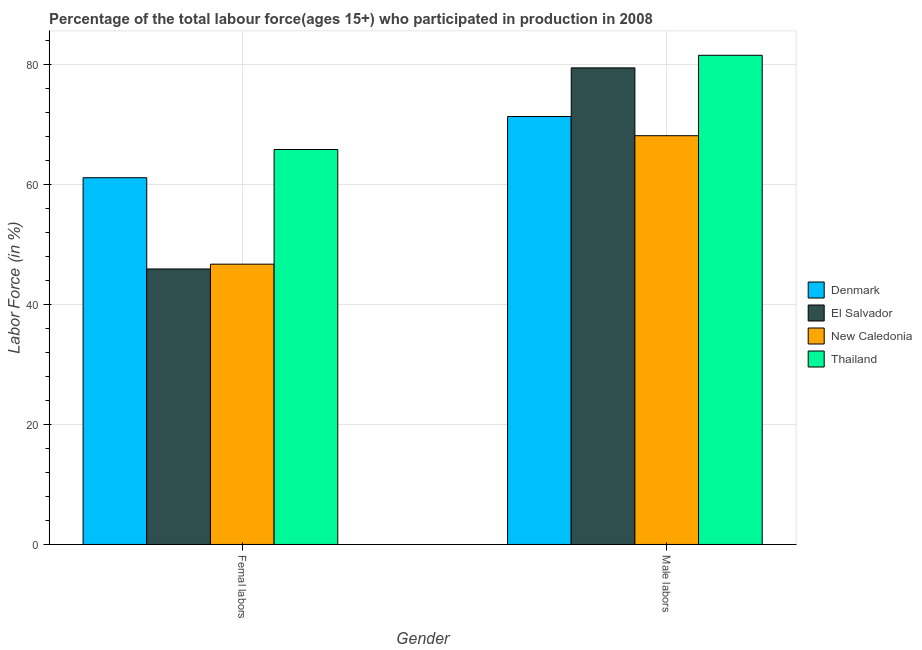How many different coloured bars are there?
Offer a very short reply. 4. Are the number of bars on each tick of the X-axis equal?
Your answer should be compact. Yes. What is the label of the 2nd group of bars from the left?
Offer a terse response. Male labors. What is the percentage of female labor force in New Caledonia?
Offer a very short reply. 46.7. Across all countries, what is the maximum percentage of female labor force?
Provide a succinct answer. 65.8. Across all countries, what is the minimum percentage of female labor force?
Make the answer very short. 45.9. In which country was the percentage of male labour force maximum?
Provide a short and direct response. Thailand. In which country was the percentage of female labor force minimum?
Your answer should be compact. El Salvador. What is the total percentage of male labour force in the graph?
Provide a short and direct response. 300.3. What is the difference between the percentage of male labour force in Denmark and that in El Salvador?
Provide a short and direct response. -8.1. What is the difference between the percentage of female labor force in Denmark and the percentage of male labour force in El Salvador?
Keep it short and to the point. -18.3. What is the average percentage of female labor force per country?
Provide a succinct answer. 54.88. What is the difference between the percentage of female labor force and percentage of male labour force in New Caledonia?
Offer a terse response. -21.4. In how many countries, is the percentage of male labour force greater than 40 %?
Ensure brevity in your answer.  4. What is the ratio of the percentage of male labour force in El Salvador to that in Thailand?
Ensure brevity in your answer.  0.97. In how many countries, is the percentage of female labor force greater than the average percentage of female labor force taken over all countries?
Give a very brief answer. 2. What does the 1st bar from the left in Male labors represents?
Offer a very short reply. Denmark. What does the 2nd bar from the right in Male labors represents?
Your response must be concise. New Caledonia. Are all the bars in the graph horizontal?
Provide a succinct answer. No. How many countries are there in the graph?
Give a very brief answer. 4. Are the values on the major ticks of Y-axis written in scientific E-notation?
Keep it short and to the point. No. Does the graph contain any zero values?
Your answer should be very brief. No. Does the graph contain grids?
Ensure brevity in your answer.  Yes. Where does the legend appear in the graph?
Ensure brevity in your answer.  Center right. How many legend labels are there?
Provide a short and direct response. 4. How are the legend labels stacked?
Provide a short and direct response. Vertical. What is the title of the graph?
Make the answer very short. Percentage of the total labour force(ages 15+) who participated in production in 2008. What is the Labor Force (in %) in Denmark in Femal labors?
Make the answer very short. 61.1. What is the Labor Force (in %) of El Salvador in Femal labors?
Make the answer very short. 45.9. What is the Labor Force (in %) in New Caledonia in Femal labors?
Provide a short and direct response. 46.7. What is the Labor Force (in %) in Thailand in Femal labors?
Provide a succinct answer. 65.8. What is the Labor Force (in %) of Denmark in Male labors?
Your answer should be very brief. 71.3. What is the Labor Force (in %) in El Salvador in Male labors?
Make the answer very short. 79.4. What is the Labor Force (in %) in New Caledonia in Male labors?
Offer a terse response. 68.1. What is the Labor Force (in %) in Thailand in Male labors?
Provide a short and direct response. 81.5. Across all Gender, what is the maximum Labor Force (in %) in Denmark?
Offer a very short reply. 71.3. Across all Gender, what is the maximum Labor Force (in %) in El Salvador?
Your answer should be very brief. 79.4. Across all Gender, what is the maximum Labor Force (in %) of New Caledonia?
Your response must be concise. 68.1. Across all Gender, what is the maximum Labor Force (in %) of Thailand?
Your answer should be very brief. 81.5. Across all Gender, what is the minimum Labor Force (in %) of Denmark?
Your response must be concise. 61.1. Across all Gender, what is the minimum Labor Force (in %) of El Salvador?
Keep it short and to the point. 45.9. Across all Gender, what is the minimum Labor Force (in %) in New Caledonia?
Provide a short and direct response. 46.7. Across all Gender, what is the minimum Labor Force (in %) in Thailand?
Provide a short and direct response. 65.8. What is the total Labor Force (in %) of Denmark in the graph?
Your answer should be compact. 132.4. What is the total Labor Force (in %) in El Salvador in the graph?
Make the answer very short. 125.3. What is the total Labor Force (in %) of New Caledonia in the graph?
Provide a short and direct response. 114.8. What is the total Labor Force (in %) of Thailand in the graph?
Offer a terse response. 147.3. What is the difference between the Labor Force (in %) in Denmark in Femal labors and that in Male labors?
Provide a short and direct response. -10.2. What is the difference between the Labor Force (in %) in El Salvador in Femal labors and that in Male labors?
Provide a short and direct response. -33.5. What is the difference between the Labor Force (in %) in New Caledonia in Femal labors and that in Male labors?
Give a very brief answer. -21.4. What is the difference between the Labor Force (in %) of Thailand in Femal labors and that in Male labors?
Ensure brevity in your answer.  -15.7. What is the difference between the Labor Force (in %) of Denmark in Femal labors and the Labor Force (in %) of El Salvador in Male labors?
Ensure brevity in your answer.  -18.3. What is the difference between the Labor Force (in %) of Denmark in Femal labors and the Labor Force (in %) of Thailand in Male labors?
Offer a terse response. -20.4. What is the difference between the Labor Force (in %) of El Salvador in Femal labors and the Labor Force (in %) of New Caledonia in Male labors?
Offer a very short reply. -22.2. What is the difference between the Labor Force (in %) of El Salvador in Femal labors and the Labor Force (in %) of Thailand in Male labors?
Offer a very short reply. -35.6. What is the difference between the Labor Force (in %) of New Caledonia in Femal labors and the Labor Force (in %) of Thailand in Male labors?
Provide a succinct answer. -34.8. What is the average Labor Force (in %) in Denmark per Gender?
Provide a succinct answer. 66.2. What is the average Labor Force (in %) of El Salvador per Gender?
Keep it short and to the point. 62.65. What is the average Labor Force (in %) in New Caledonia per Gender?
Your response must be concise. 57.4. What is the average Labor Force (in %) of Thailand per Gender?
Provide a short and direct response. 73.65. What is the difference between the Labor Force (in %) in Denmark and Labor Force (in %) in El Salvador in Femal labors?
Give a very brief answer. 15.2. What is the difference between the Labor Force (in %) of Denmark and Labor Force (in %) of New Caledonia in Femal labors?
Make the answer very short. 14.4. What is the difference between the Labor Force (in %) of Denmark and Labor Force (in %) of Thailand in Femal labors?
Keep it short and to the point. -4.7. What is the difference between the Labor Force (in %) in El Salvador and Labor Force (in %) in New Caledonia in Femal labors?
Your answer should be compact. -0.8. What is the difference between the Labor Force (in %) of El Salvador and Labor Force (in %) of Thailand in Femal labors?
Offer a terse response. -19.9. What is the difference between the Labor Force (in %) in New Caledonia and Labor Force (in %) in Thailand in Femal labors?
Make the answer very short. -19.1. What is the difference between the Labor Force (in %) of Denmark and Labor Force (in %) of El Salvador in Male labors?
Your response must be concise. -8.1. What is the difference between the Labor Force (in %) in Denmark and Labor Force (in %) in Thailand in Male labors?
Give a very brief answer. -10.2. What is the ratio of the Labor Force (in %) in Denmark in Femal labors to that in Male labors?
Provide a short and direct response. 0.86. What is the ratio of the Labor Force (in %) of El Salvador in Femal labors to that in Male labors?
Your answer should be very brief. 0.58. What is the ratio of the Labor Force (in %) of New Caledonia in Femal labors to that in Male labors?
Ensure brevity in your answer.  0.69. What is the ratio of the Labor Force (in %) in Thailand in Femal labors to that in Male labors?
Ensure brevity in your answer.  0.81. What is the difference between the highest and the second highest Labor Force (in %) of El Salvador?
Offer a very short reply. 33.5. What is the difference between the highest and the second highest Labor Force (in %) of New Caledonia?
Ensure brevity in your answer.  21.4. What is the difference between the highest and the lowest Labor Force (in %) in El Salvador?
Keep it short and to the point. 33.5. What is the difference between the highest and the lowest Labor Force (in %) in New Caledonia?
Ensure brevity in your answer.  21.4. What is the difference between the highest and the lowest Labor Force (in %) in Thailand?
Your response must be concise. 15.7. 